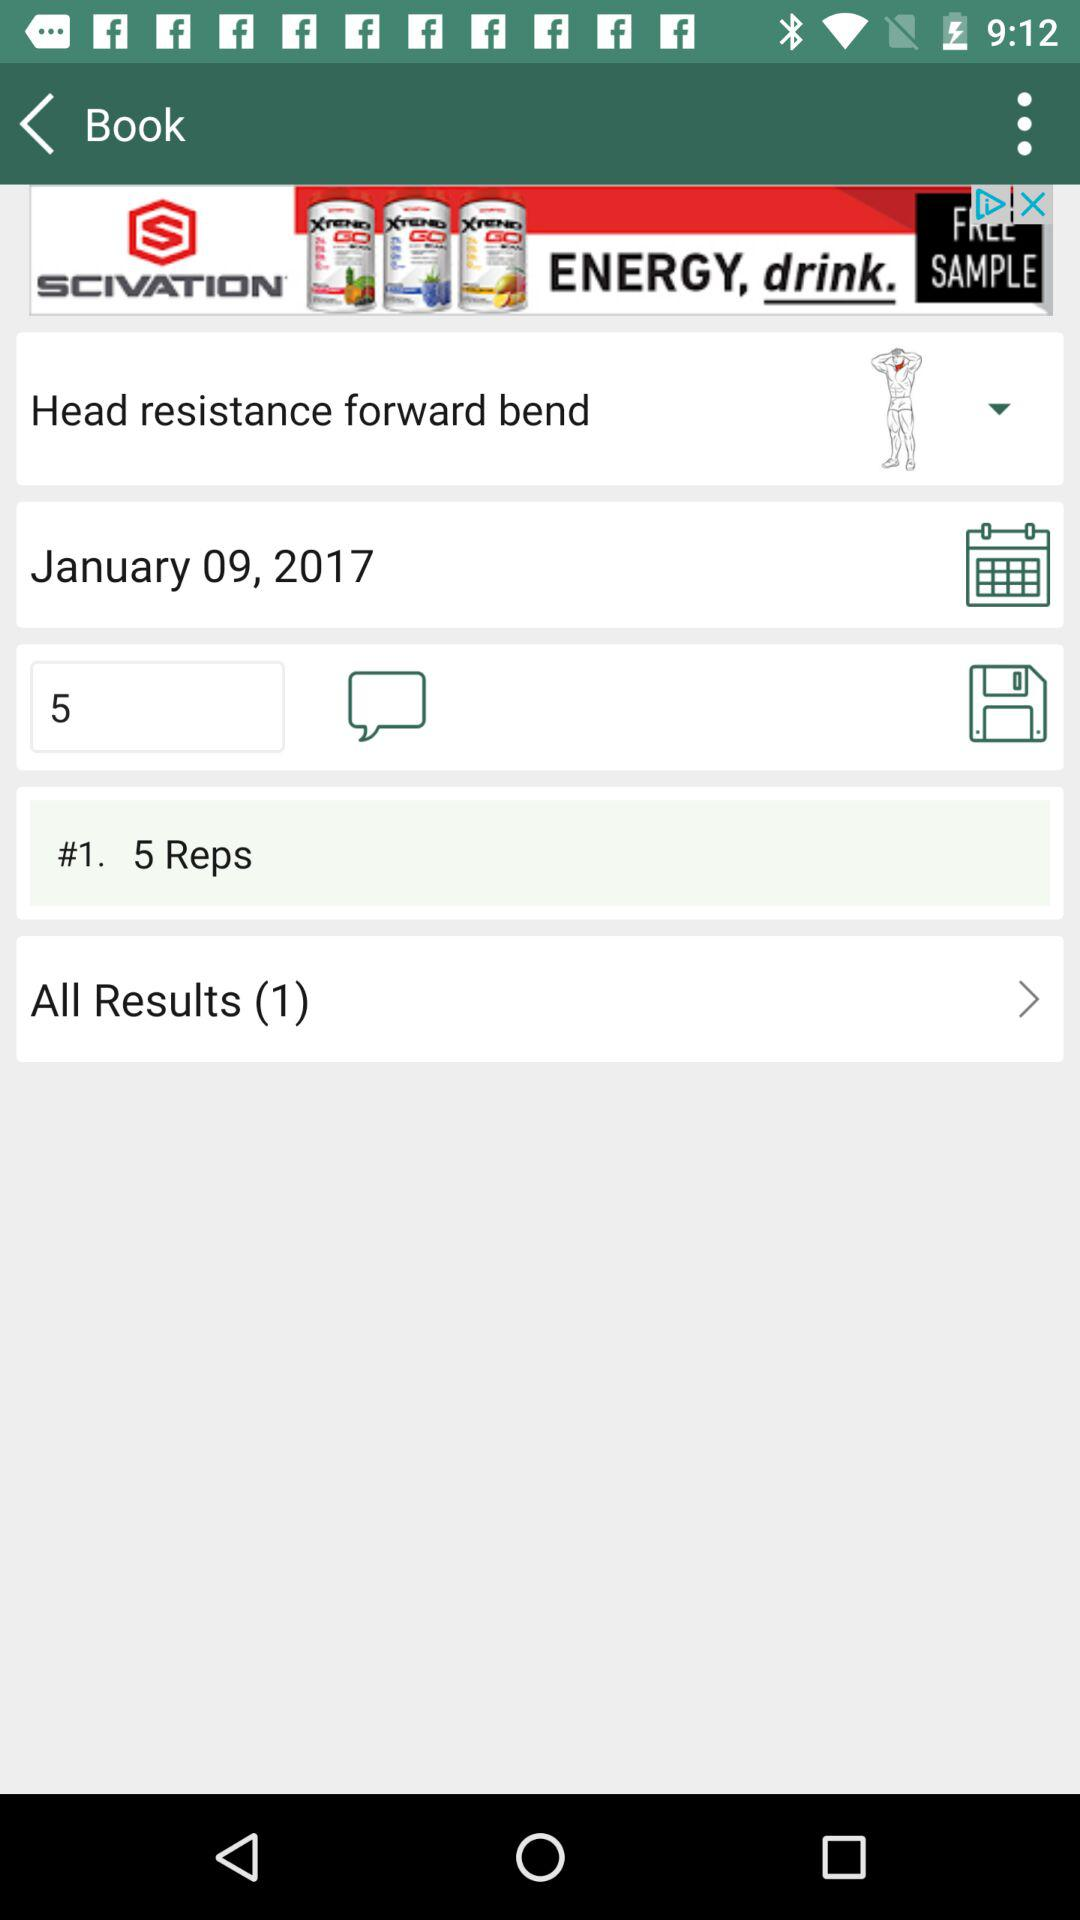How many reps are there? There are 5 reps. 